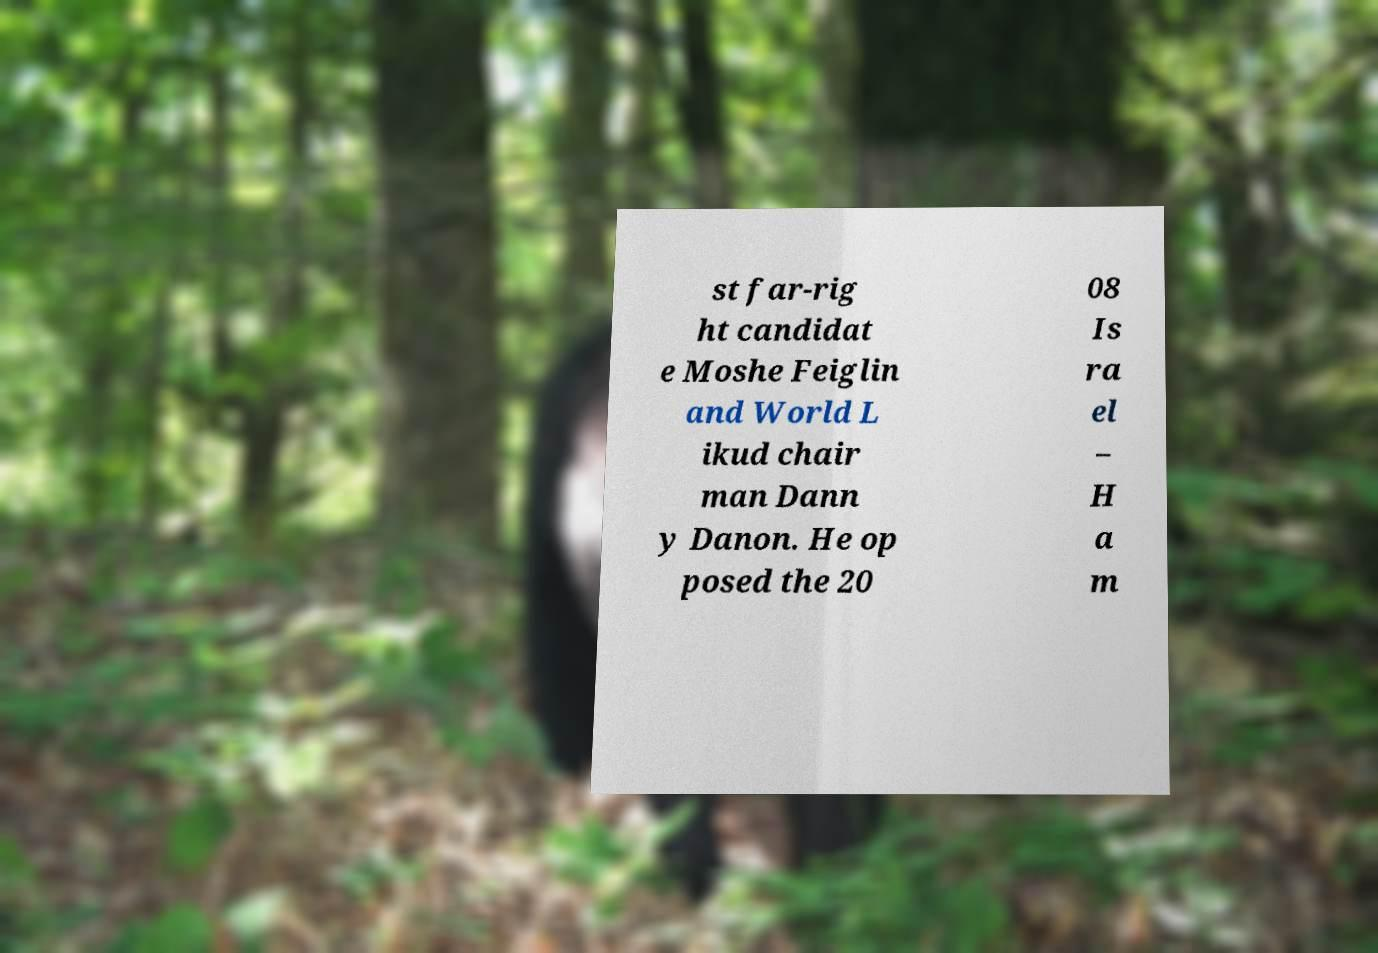Please identify and transcribe the text found in this image. st far-rig ht candidat e Moshe Feiglin and World L ikud chair man Dann y Danon. He op posed the 20 08 Is ra el – H a m 